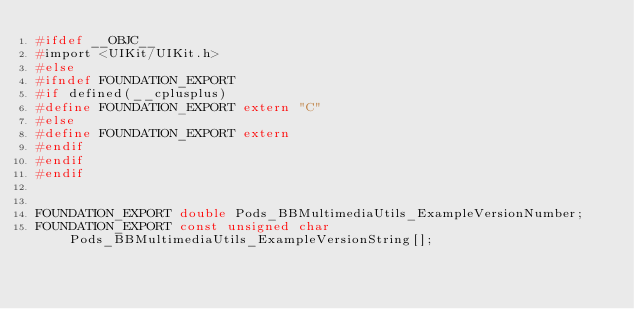Convert code to text. <code><loc_0><loc_0><loc_500><loc_500><_C_>#ifdef __OBJC__
#import <UIKit/UIKit.h>
#else
#ifndef FOUNDATION_EXPORT
#if defined(__cplusplus)
#define FOUNDATION_EXPORT extern "C"
#else
#define FOUNDATION_EXPORT extern
#endif
#endif
#endif


FOUNDATION_EXPORT double Pods_BBMultimediaUtils_ExampleVersionNumber;
FOUNDATION_EXPORT const unsigned char Pods_BBMultimediaUtils_ExampleVersionString[];

</code> 